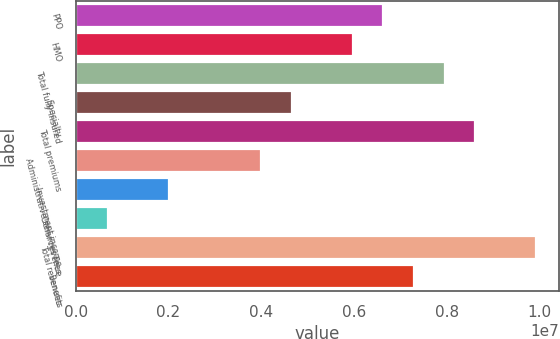Convert chart to OTSL. <chart><loc_0><loc_0><loc_500><loc_500><bar_chart><fcel>PPO<fcel>HMO<fcel>Total fully-insured<fcel>Specialty<fcel>Total premiums<fcel>Administrative services fees<fcel>Investment income<fcel>Other revenue<fcel>Total revenues<fcel>Benefits<nl><fcel>6.63542e+06<fcel>5.9754e+06<fcel>7.95546e+06<fcel>4.65536e+06<fcel>8.61548e+06<fcel>3.99534e+06<fcel>2.01529e+06<fcel>695248<fcel>9.93551e+06<fcel>7.29544e+06<nl></chart> 